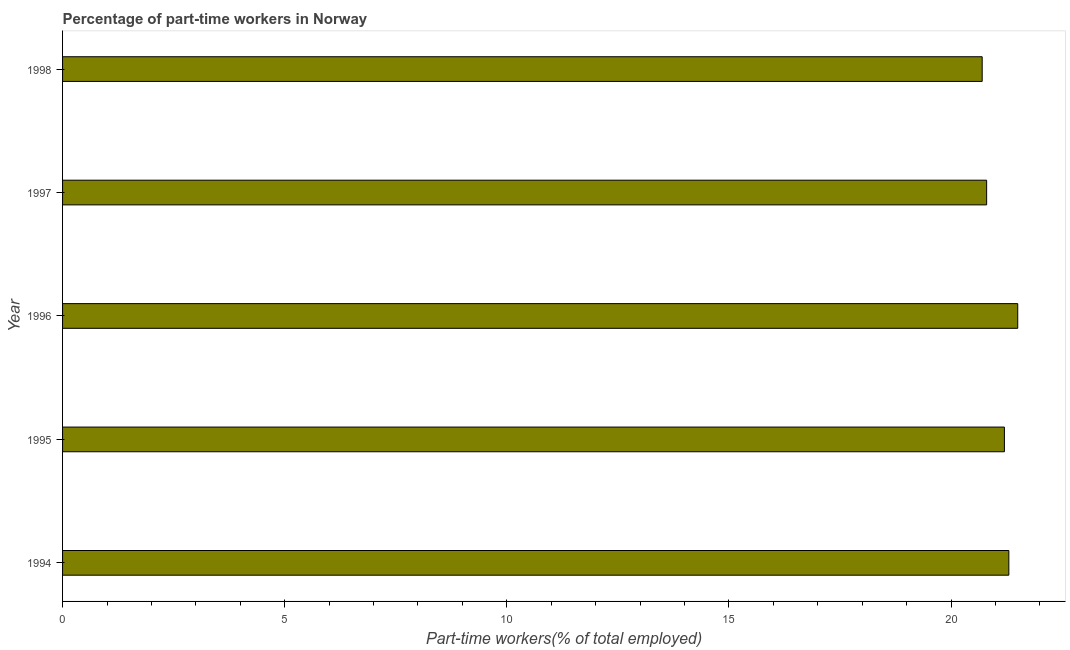Does the graph contain any zero values?
Offer a very short reply. No. What is the title of the graph?
Give a very brief answer. Percentage of part-time workers in Norway. What is the label or title of the X-axis?
Ensure brevity in your answer.  Part-time workers(% of total employed). What is the label or title of the Y-axis?
Your response must be concise. Year. What is the percentage of part-time workers in 1994?
Your response must be concise. 21.3. Across all years, what is the maximum percentage of part-time workers?
Give a very brief answer. 21.5. Across all years, what is the minimum percentage of part-time workers?
Offer a very short reply. 20.7. What is the sum of the percentage of part-time workers?
Provide a succinct answer. 105.5. What is the difference between the percentage of part-time workers in 1995 and 1996?
Your answer should be very brief. -0.3. What is the average percentage of part-time workers per year?
Keep it short and to the point. 21.1. What is the median percentage of part-time workers?
Your response must be concise. 21.2. Do a majority of the years between 1998 and 1995 (inclusive) have percentage of part-time workers greater than 16 %?
Keep it short and to the point. Yes. What is the ratio of the percentage of part-time workers in 1994 to that in 1997?
Provide a succinct answer. 1.02. Is the difference between the percentage of part-time workers in 1994 and 1998 greater than the difference between any two years?
Provide a succinct answer. No. What is the difference between the highest and the lowest percentage of part-time workers?
Make the answer very short. 0.8. In how many years, is the percentage of part-time workers greater than the average percentage of part-time workers taken over all years?
Provide a short and direct response. 3. What is the difference between two consecutive major ticks on the X-axis?
Give a very brief answer. 5. What is the Part-time workers(% of total employed) in 1994?
Offer a terse response. 21.3. What is the Part-time workers(% of total employed) of 1995?
Provide a short and direct response. 21.2. What is the Part-time workers(% of total employed) of 1996?
Your answer should be compact. 21.5. What is the Part-time workers(% of total employed) in 1997?
Provide a succinct answer. 20.8. What is the Part-time workers(% of total employed) of 1998?
Ensure brevity in your answer.  20.7. What is the difference between the Part-time workers(% of total employed) in 1994 and 1995?
Ensure brevity in your answer.  0.1. What is the difference between the Part-time workers(% of total employed) in 1994 and 1997?
Your answer should be very brief. 0.5. What is the difference between the Part-time workers(% of total employed) in 1995 and 1996?
Ensure brevity in your answer.  -0.3. What is the difference between the Part-time workers(% of total employed) in 1995 and 1997?
Give a very brief answer. 0.4. What is the difference between the Part-time workers(% of total employed) in 1997 and 1998?
Your response must be concise. 0.1. What is the ratio of the Part-time workers(% of total employed) in 1994 to that in 1997?
Give a very brief answer. 1.02. What is the ratio of the Part-time workers(% of total employed) in 1994 to that in 1998?
Provide a succinct answer. 1.03. What is the ratio of the Part-time workers(% of total employed) in 1995 to that in 1996?
Provide a short and direct response. 0.99. What is the ratio of the Part-time workers(% of total employed) in 1995 to that in 1997?
Ensure brevity in your answer.  1.02. What is the ratio of the Part-time workers(% of total employed) in 1996 to that in 1997?
Provide a succinct answer. 1.03. What is the ratio of the Part-time workers(% of total employed) in 1996 to that in 1998?
Provide a short and direct response. 1.04. 